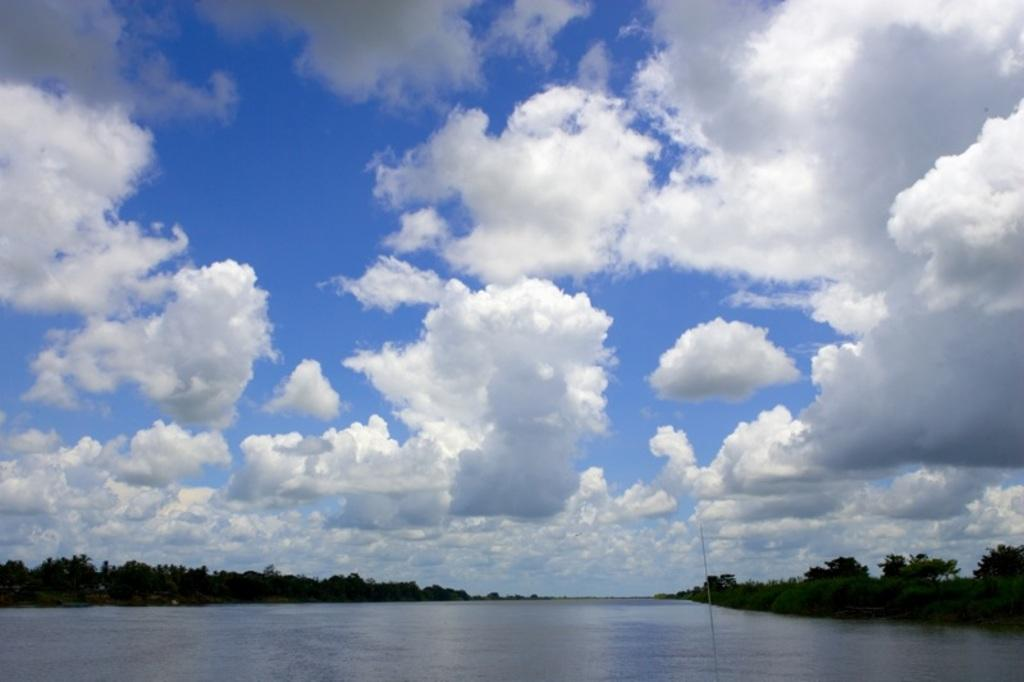What type of natural feature is present in the image? There is a river in the image. What surrounds the river in the image? There are trees on either side of the river. What is visible at the top of the image? The sky is visible at the top of the image. What can be seen in the sky in the image? There are clouds in the sky. How many pears are balanced on the branches of the trees in the image? There are no pears visible in the image; it features a river with trees on either side. What type of vehicles can be seen driving along the river in the image? There are no vehicles present in the image; it features a river with trees on either side and a sky with clouds. 